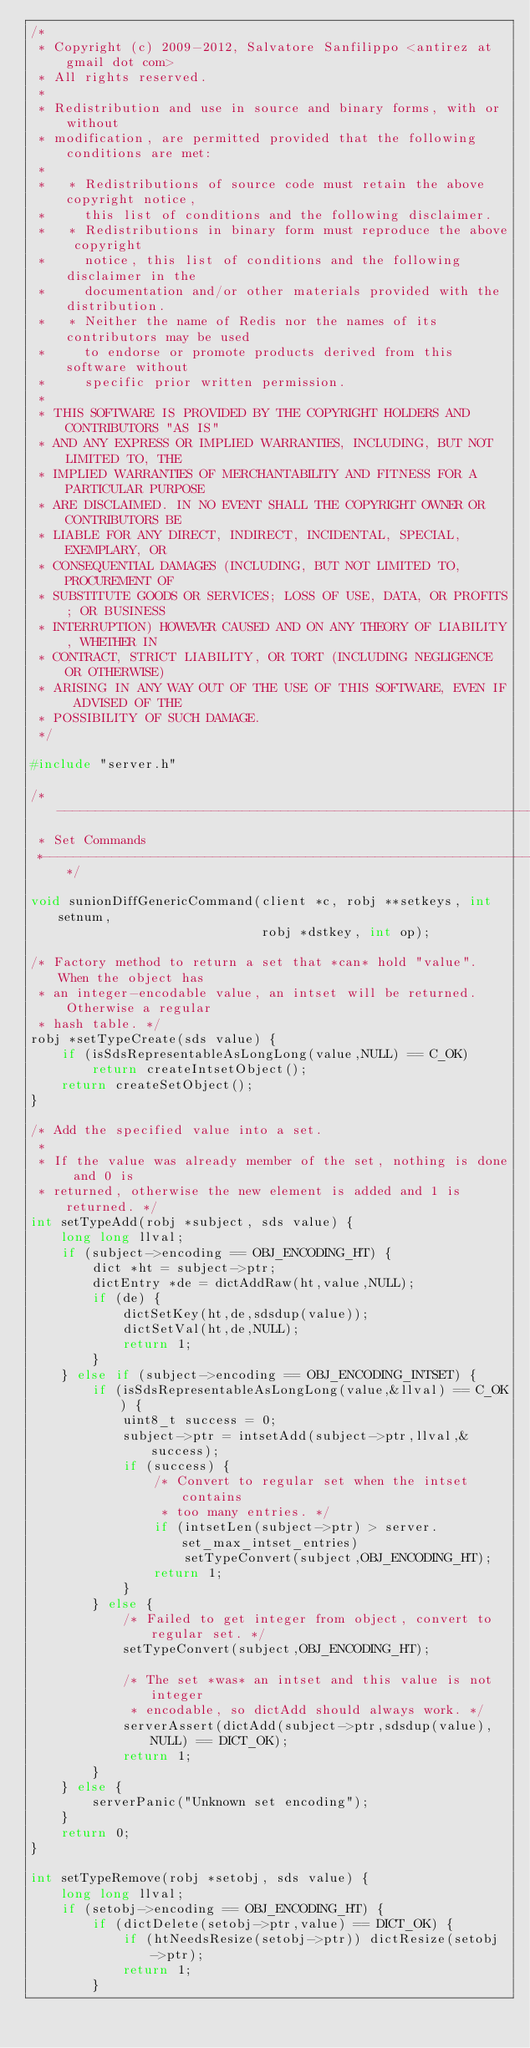Convert code to text. <code><loc_0><loc_0><loc_500><loc_500><_C_>/*
 * Copyright (c) 2009-2012, Salvatore Sanfilippo <antirez at gmail dot com>
 * All rights reserved.
 *
 * Redistribution and use in source and binary forms, with or without
 * modification, are permitted provided that the following conditions are met:
 *
 *   * Redistributions of source code must retain the above copyright notice,
 *     this list of conditions and the following disclaimer.
 *   * Redistributions in binary form must reproduce the above copyright
 *     notice, this list of conditions and the following disclaimer in the
 *     documentation and/or other materials provided with the distribution.
 *   * Neither the name of Redis nor the names of its contributors may be used
 *     to endorse or promote products derived from this software without
 *     specific prior written permission.
 *
 * THIS SOFTWARE IS PROVIDED BY THE COPYRIGHT HOLDERS AND CONTRIBUTORS "AS IS"
 * AND ANY EXPRESS OR IMPLIED WARRANTIES, INCLUDING, BUT NOT LIMITED TO, THE
 * IMPLIED WARRANTIES OF MERCHANTABILITY AND FITNESS FOR A PARTICULAR PURPOSE
 * ARE DISCLAIMED. IN NO EVENT SHALL THE COPYRIGHT OWNER OR CONTRIBUTORS BE
 * LIABLE FOR ANY DIRECT, INDIRECT, INCIDENTAL, SPECIAL, EXEMPLARY, OR
 * CONSEQUENTIAL DAMAGES (INCLUDING, BUT NOT LIMITED TO, PROCUREMENT OF
 * SUBSTITUTE GOODS OR SERVICES; LOSS OF USE, DATA, OR PROFITS; OR BUSINESS
 * INTERRUPTION) HOWEVER CAUSED AND ON ANY THEORY OF LIABILITY, WHETHER IN
 * CONTRACT, STRICT LIABILITY, OR TORT (INCLUDING NEGLIGENCE OR OTHERWISE)
 * ARISING IN ANY WAY OUT OF THE USE OF THIS SOFTWARE, EVEN IF ADVISED OF THE
 * POSSIBILITY OF SUCH DAMAGE.
 */

#include "server.h"

/*-----------------------------------------------------------------------------
 * Set Commands
 *----------------------------------------------------------------------------*/

void sunionDiffGenericCommand(client *c, robj **setkeys, int setnum,
                              robj *dstkey, int op);

/* Factory method to return a set that *can* hold "value". When the object has
 * an integer-encodable value, an intset will be returned. Otherwise a regular
 * hash table. */
robj *setTypeCreate(sds value) {
    if (isSdsRepresentableAsLongLong(value,NULL) == C_OK)
        return createIntsetObject();
    return createSetObject();
}

/* Add the specified value into a set.
 *
 * If the value was already member of the set, nothing is done and 0 is
 * returned, otherwise the new element is added and 1 is returned. */
int setTypeAdd(robj *subject, sds value) {
    long long llval;
    if (subject->encoding == OBJ_ENCODING_HT) {
        dict *ht = subject->ptr;
        dictEntry *de = dictAddRaw(ht,value,NULL);
        if (de) {
            dictSetKey(ht,de,sdsdup(value));
            dictSetVal(ht,de,NULL);
            return 1;
        }
    } else if (subject->encoding == OBJ_ENCODING_INTSET) {
        if (isSdsRepresentableAsLongLong(value,&llval) == C_OK) {
            uint8_t success = 0;
            subject->ptr = intsetAdd(subject->ptr,llval,&success);
            if (success) {
                /* Convert to regular set when the intset contains
                 * too many entries. */
                if (intsetLen(subject->ptr) > server.set_max_intset_entries)
                    setTypeConvert(subject,OBJ_ENCODING_HT);
                return 1;
            }
        } else {
            /* Failed to get integer from object, convert to regular set. */
            setTypeConvert(subject,OBJ_ENCODING_HT);

            /* The set *was* an intset and this value is not integer
             * encodable, so dictAdd should always work. */
            serverAssert(dictAdd(subject->ptr,sdsdup(value),NULL) == DICT_OK);
            return 1;
        }
    } else {
        serverPanic("Unknown set encoding");
    }
    return 0;
}

int setTypeRemove(robj *setobj, sds value) {
    long long llval;
    if (setobj->encoding == OBJ_ENCODING_HT) {
        if (dictDelete(setobj->ptr,value) == DICT_OK) {
            if (htNeedsResize(setobj->ptr)) dictResize(setobj->ptr);
            return 1;
        }</code> 